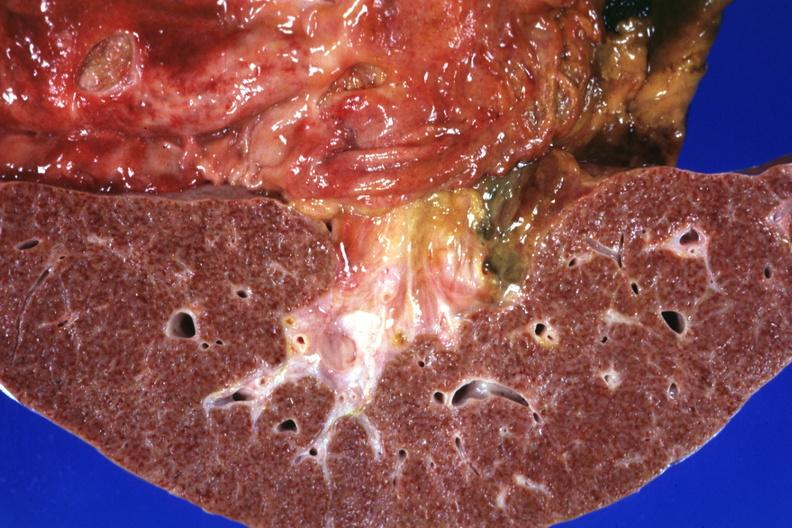s hepatobiliary present?
Answer the question using a single word or phrase. Yes 